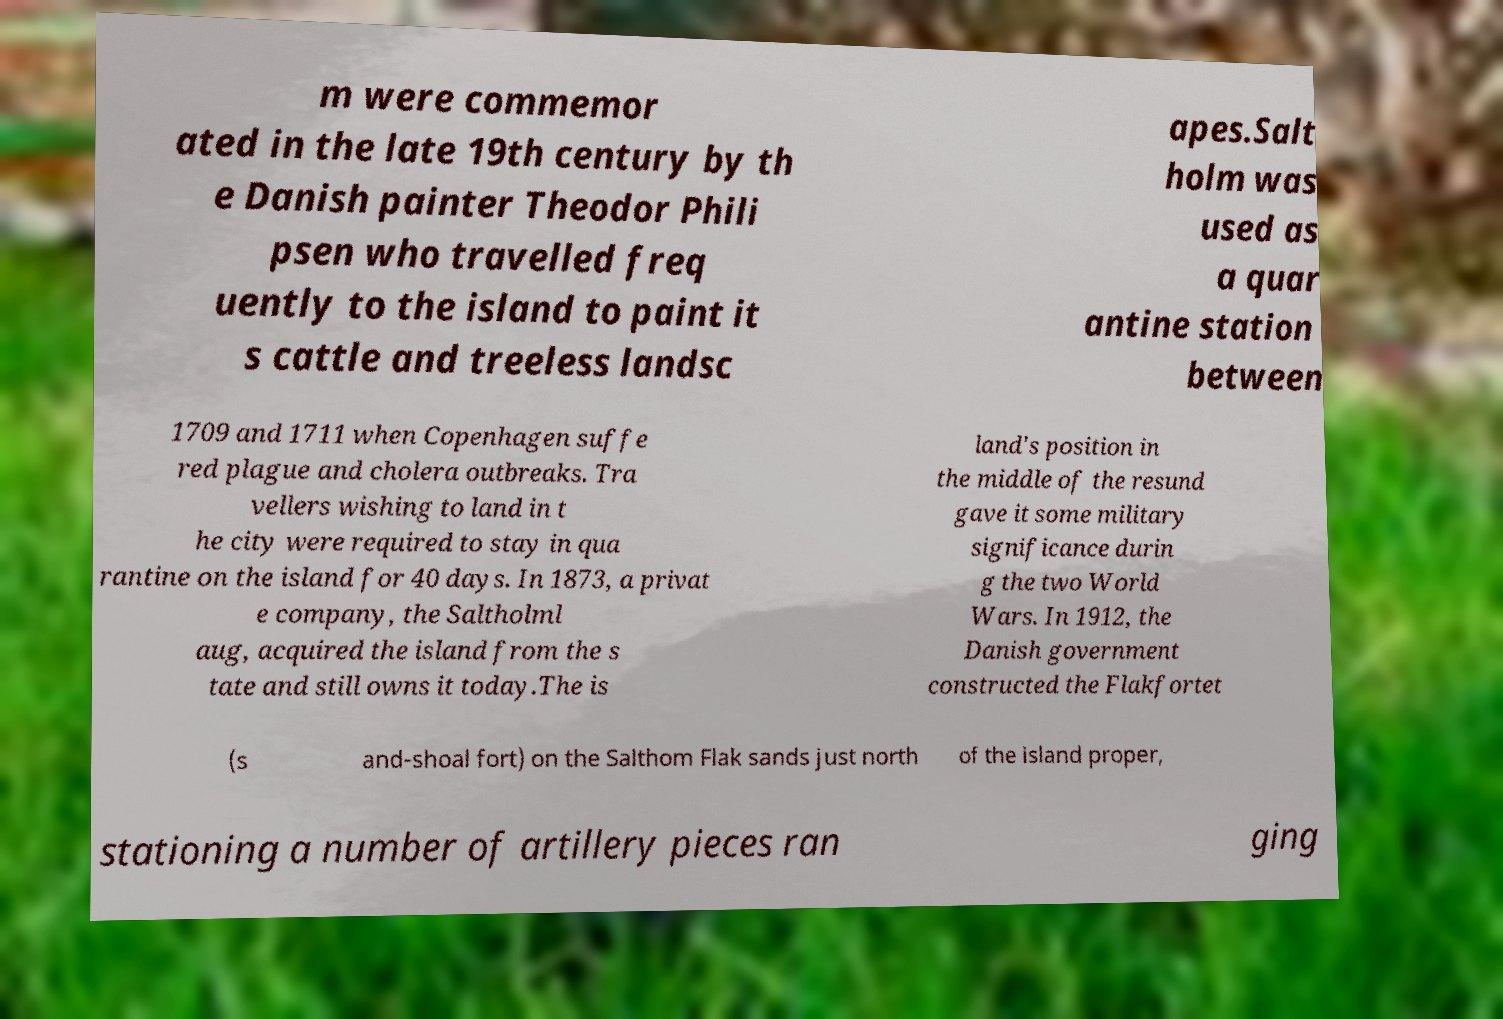For documentation purposes, I need the text within this image transcribed. Could you provide that? m were commemor ated in the late 19th century by th e Danish painter Theodor Phili psen who travelled freq uently to the island to paint it s cattle and treeless landsc apes.Salt holm was used as a quar antine station between 1709 and 1711 when Copenhagen suffe red plague and cholera outbreaks. Tra vellers wishing to land in t he city were required to stay in qua rantine on the island for 40 days. In 1873, a privat e company, the Saltholml aug, acquired the island from the s tate and still owns it today.The is land's position in the middle of the resund gave it some military significance durin g the two World Wars. In 1912, the Danish government constructed the Flakfortet (s and-shoal fort) on the Salthom Flak sands just north of the island proper, stationing a number of artillery pieces ran ging 